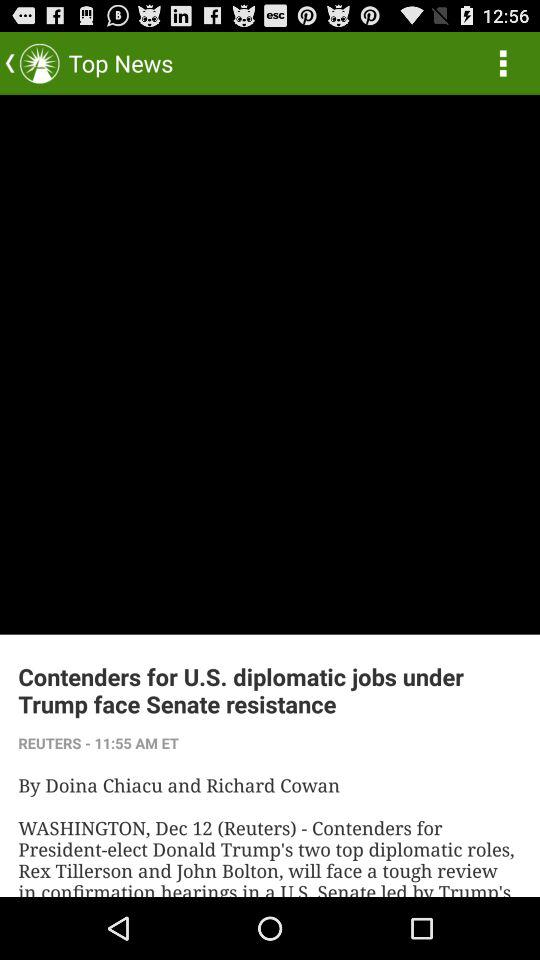What date was the article published?
When the provided information is insufficient, respond with <no answer>. <no answer> 